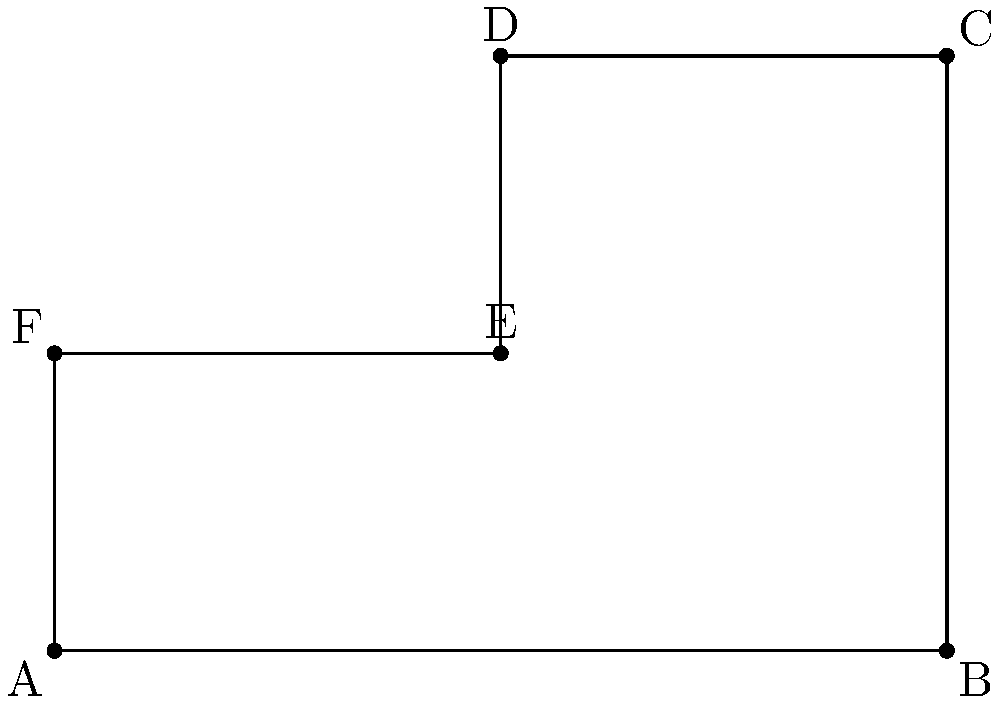In the mythical tale of Theseus and the Minotaur, the Labyrinth is represented as a polygon on a coordinate plane. The vertices of this polygon are A(0,0), B(6,0), C(6,4), D(3,4), E(3,2), and F(0,2). Calculate the area of the Labyrinth where Theseus fought the Minotaur. To find the area of the polygon representing the Labyrinth, we can divide it into simpler shapes and add their areas:

1. First, let's divide the polygon into a rectangle and two triangles.

2. Rectangle ABEF:
   Width = 6 units
   Height = 2 units
   Area of rectangle = $6 \times 2 = 12$ square units

3. Triangle BCD:
   Base = 3 units
   Height = 2 units
   Area of triangle BCD = $\frac{1}{2} \times 3 \times 2 = 3$ square units

4. Triangle DEF:
   Base = 3 units
   Height = 2 units
   Area of triangle DEF = $\frac{1}{2} \times 3 \times 2 = 3$ square units

5. Total area of the Labyrinth:
   $\text{Area}_{\text{total}} = \text{Area}_{\text{rectangle}} + \text{Area}_{\text{triangle BCD}} + \text{Area}_{\text{triangle DEF}}$
   $\text{Area}_{\text{total}} = 12 + 3 + 3 = 18$ square units

Therefore, the area of the Labyrinth where Theseus fought the Minotaur is 18 square units.
Answer: 18 square units 